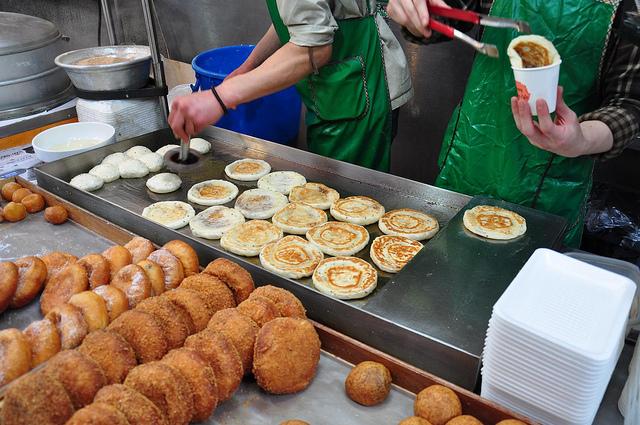Are the cooking breakfast?
Answer briefly. Yes. What color is the bucket?
Be succinct. Blue. Is there styrofoam in the image?
Give a very brief answer. Yes. Are there any people in the photo?
Quick response, please. Yes. How many donuts appear to have NOT been flipped?
Give a very brief answer. 9. Does the jelly go on all the food?
Quick response, please. No. What are the donuts on?
Write a very short answer. Tray. 